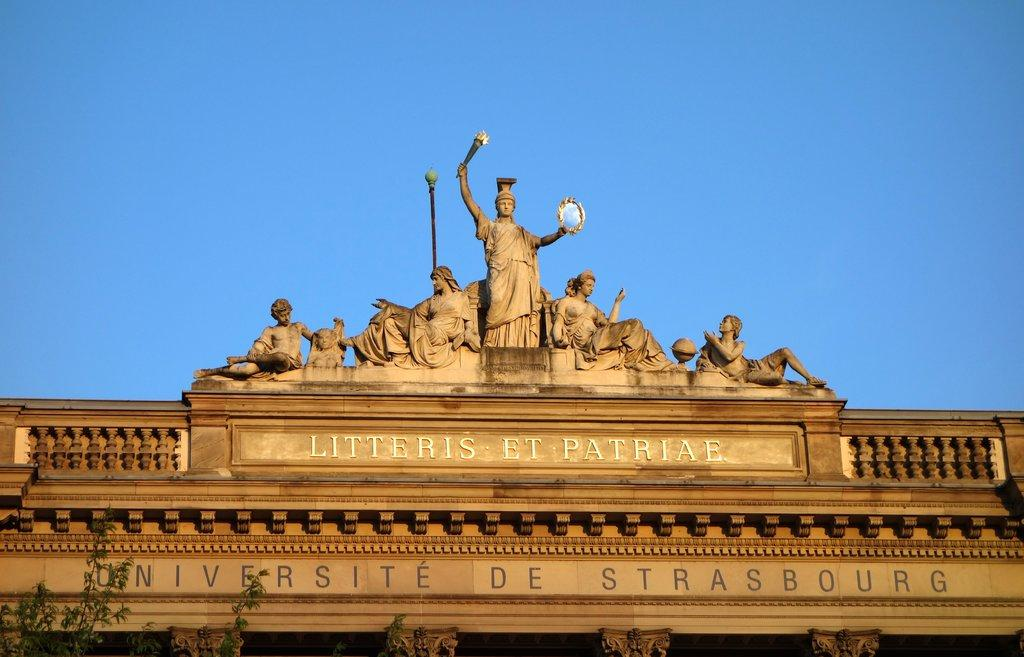What type of art is present in the image? There are sculptures in the image. What else can be seen in the image besides the sculptures? There is text and trees visible in the image. What is the color of the sky in the image? The sky is blue in the image. Can you tell me how many apples are hanging from the trees in the image? There are no apples present in the image; it features sculptures, text, and trees. What type of park is depicted in the image? There is no park depicted in the image; it features sculptures, text, and trees. 